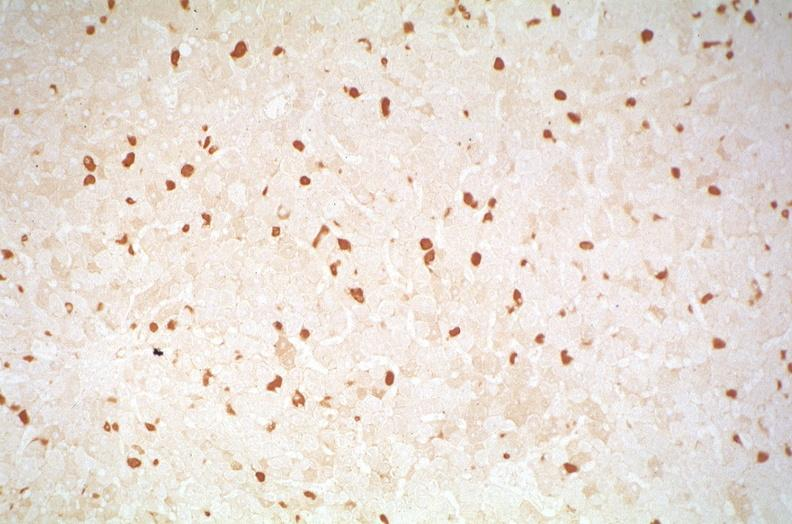what is present?
Answer the question using a single word or phrase. Liver 